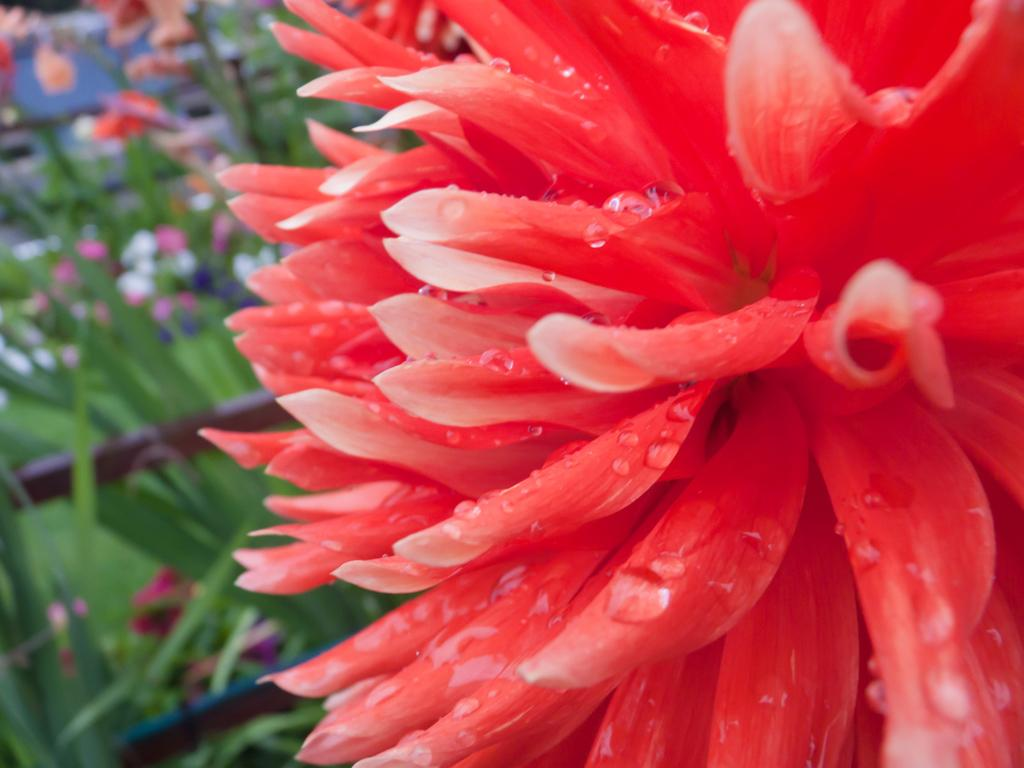What is the main subject of the image? There is a flower in the image. Can you describe the background of the image? The background of the image is blurry. What else can be seen in the background of the image? There are plants and flowers in the background of the image. What arithmetic problem is being solved by the flower in the image? There is no arithmetic problem being solved by the flower in the image, as flowers do not have the ability to solve mathematical problems. 